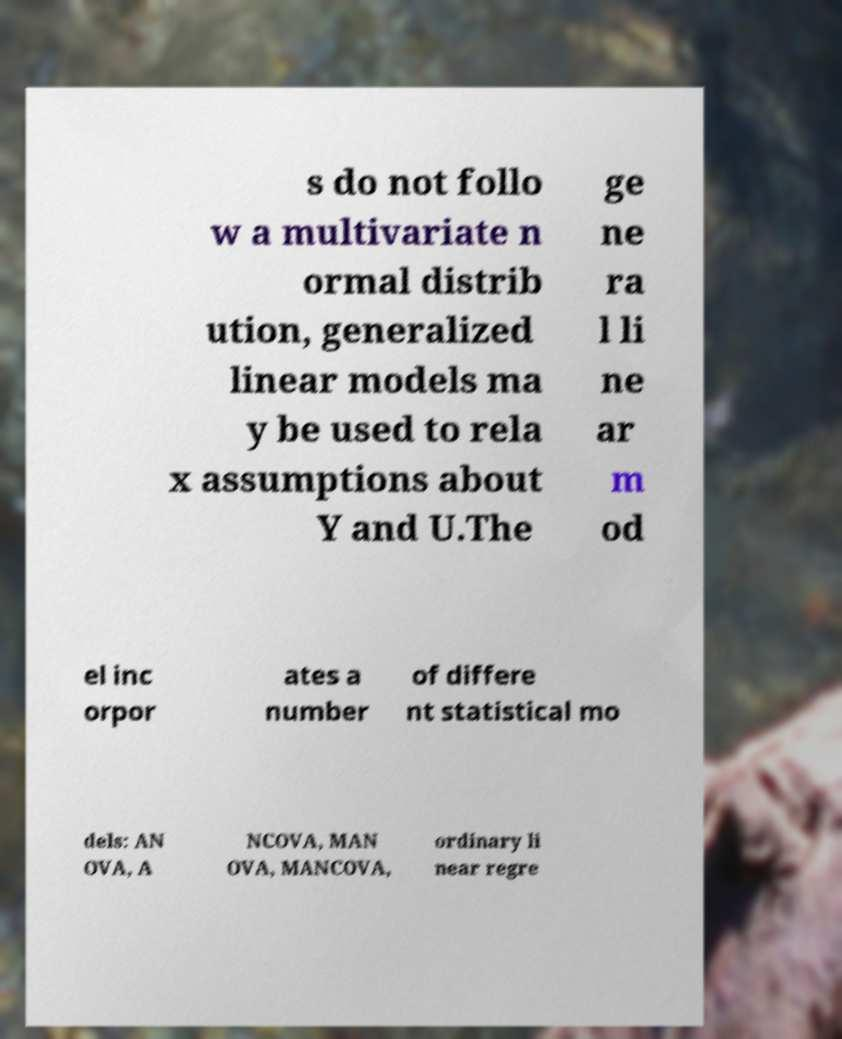Can you accurately transcribe the text from the provided image for me? s do not follo w a multivariate n ormal distrib ution, generalized linear models ma y be used to rela x assumptions about Y and U.The ge ne ra l li ne ar m od el inc orpor ates a number of differe nt statistical mo dels: AN OVA, A NCOVA, MAN OVA, MANCOVA, ordinary li near regre 